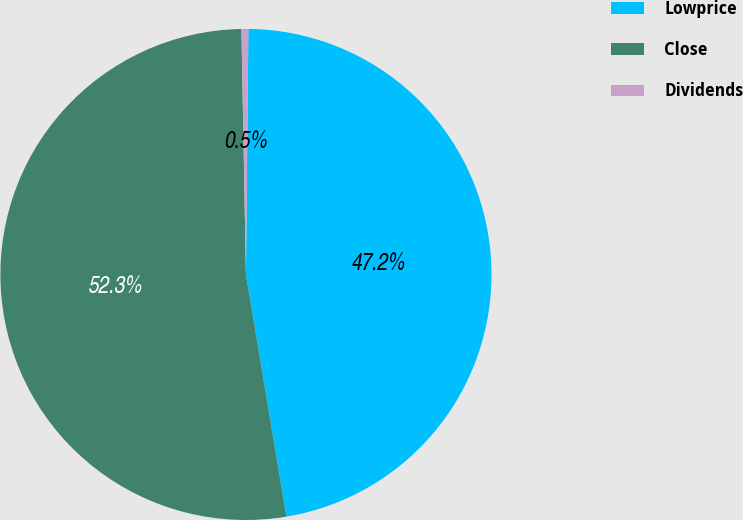Convert chart. <chart><loc_0><loc_0><loc_500><loc_500><pie_chart><fcel>Lowprice<fcel>Close<fcel>Dividends<nl><fcel>47.2%<fcel>52.34%<fcel>0.45%<nl></chart> 